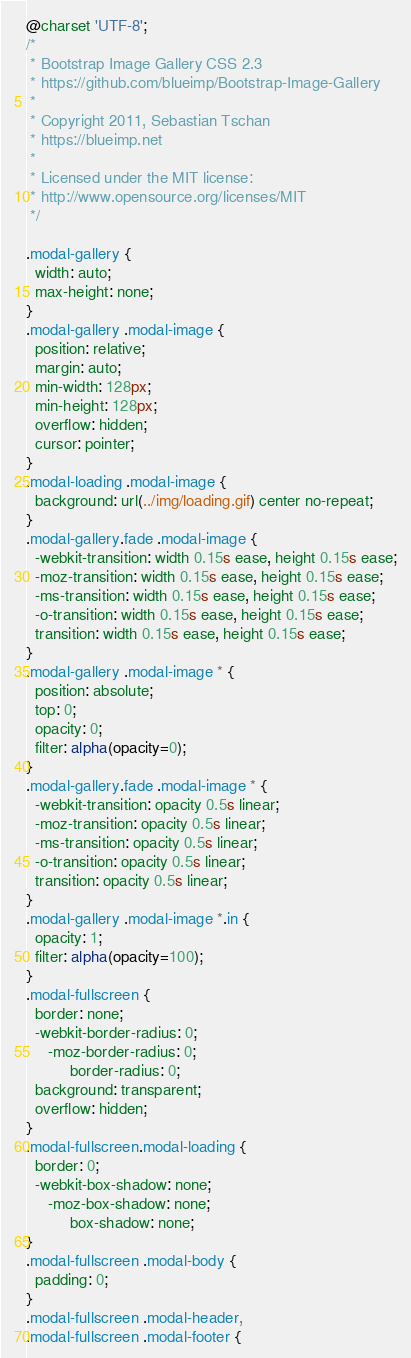<code> <loc_0><loc_0><loc_500><loc_500><_CSS_>@charset 'UTF-8';
/*
 * Bootstrap Image Gallery CSS 2.3
 * https://github.com/blueimp/Bootstrap-Image-Gallery
 *
 * Copyright 2011, Sebastian Tschan
 * https://blueimp.net
 *
 * Licensed under the MIT license:
 * http://www.opensource.org/licenses/MIT
 */

.modal-gallery {
  width: auto;
  max-height: none;
}
.modal-gallery .modal-image {
  position: relative;
  margin: auto;
  min-width: 128px;
  min-height: 128px;
  overflow: hidden;
  cursor: pointer;
}
.modal-loading .modal-image {
  background: url(../img/loading.gif) center no-repeat;
}
.modal-gallery.fade .modal-image {
  -webkit-transition: width 0.15s ease, height 0.15s ease;
  -moz-transition: width 0.15s ease, height 0.15s ease;
  -ms-transition: width 0.15s ease, height 0.15s ease;
  -o-transition: width 0.15s ease, height 0.15s ease;
  transition: width 0.15s ease, height 0.15s ease;
}
.modal-gallery .modal-image * {
  position: absolute;
  top: 0;
  opacity: 0;
  filter: alpha(opacity=0);
}
.modal-gallery.fade .modal-image * {
  -webkit-transition: opacity 0.5s linear;
  -moz-transition: opacity 0.5s linear;
  -ms-transition: opacity 0.5s linear;
  -o-transition: opacity 0.5s linear;
  transition: opacity 0.5s linear;
}
.modal-gallery .modal-image *.in {
  opacity: 1;
  filter: alpha(opacity=100);
}
.modal-fullscreen {
  border: none;
  -webkit-border-radius: 0;
     -moz-border-radius: 0;
          border-radius: 0;
  background: transparent;
  overflow: hidden;
}
.modal-fullscreen.modal-loading {
  border: 0;
  -webkit-box-shadow: none;
     -moz-box-shadow: none;
          box-shadow: none;
}
.modal-fullscreen .modal-body {
  padding: 0;
}
.modal-fullscreen .modal-header,
.modal-fullscreen .modal-footer {</code> 